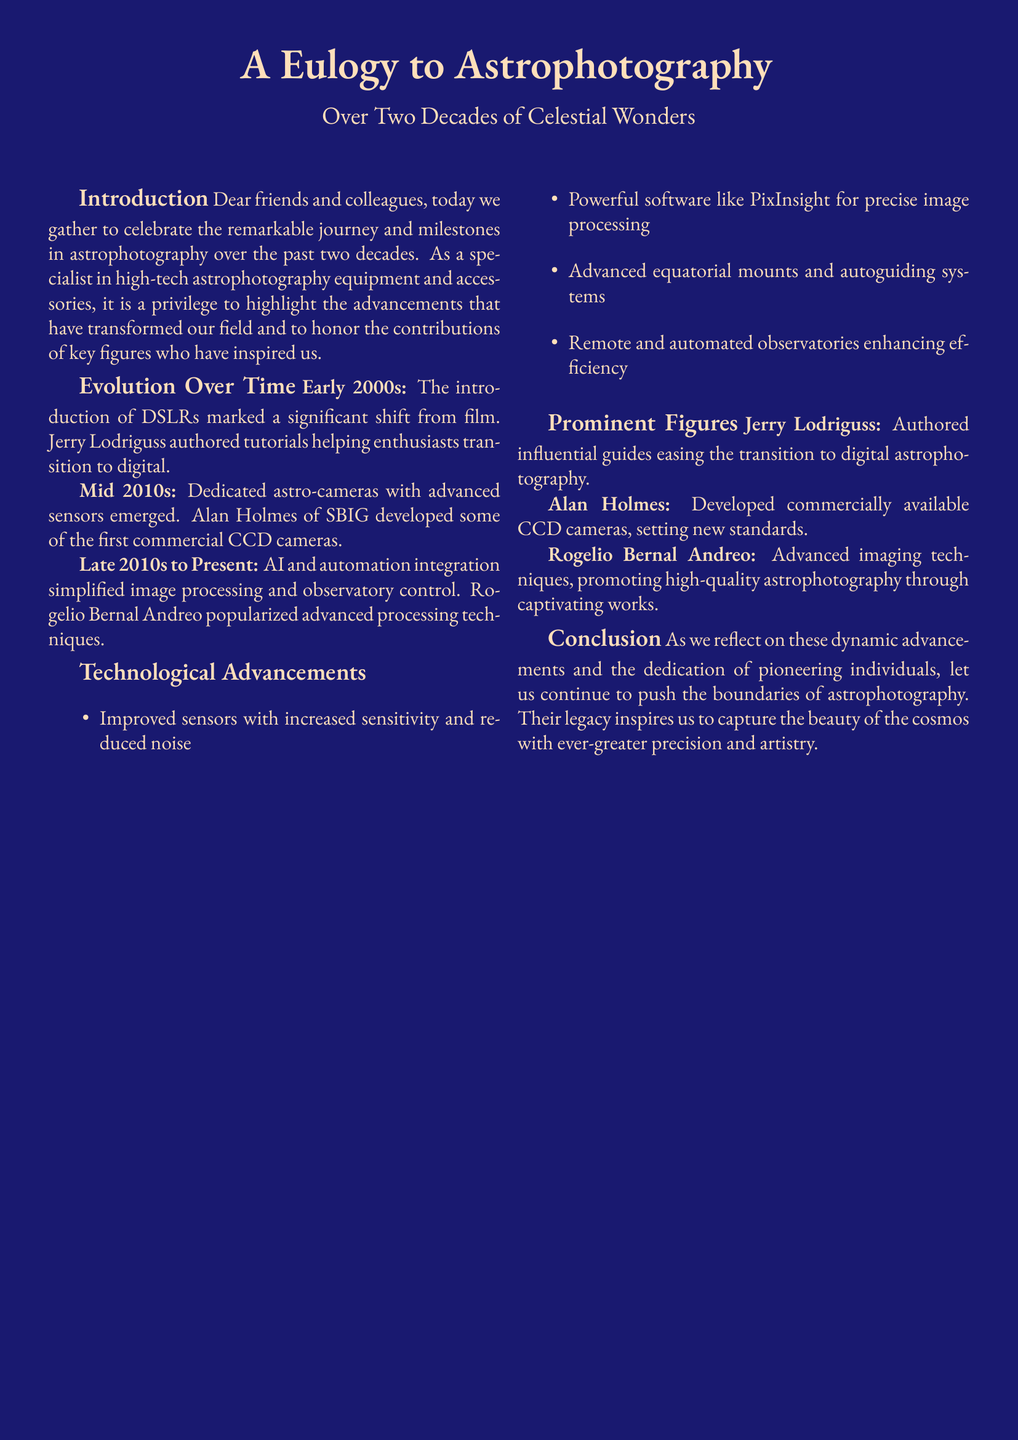What significant shift occurred in the early 2000s? The introduction of DSLRs marked a significant shift from film in astrophotography.
Answer: DSLRs Who authored tutorials for enthusiasts in the early 2000s? Jerry Lodriguss helped ease the transition to digital with his tutorials.
Answer: Jerry Lodriguss Which technology did Alan Holmes develop in the mid 2010s? Alan Holmes developed some of the first commercial CCD cameras.
Answer: CCD cameras What is a major software mentioned for image processing? The document highlights the use of PixInsight as powerful software for image processing.
Answer: PixInsight What type of advancements have improved the efficiency of observatories? Remote and automated observatories have enhanced efficiency in astrophotography.
Answer: Remote and automated observatories Who popularized advanced processing techniques in astrophotography? Rogelio Bernal Andreo is mentioned for popularizing advanced techniques.
Answer: Rogelio Bernal Andreo What contribution did Jerry Lodriguss make to the field? Jerry Lodriguss authored influential guides easing the transition to digital astrophotography.
Answer: Influential guides What era marks the emergence of dedicated astro-cameras? The mid 2010s is when dedicated astro-cameras with advanced sensors began to emerge.
Answer: Mid 2010s What is the color of the page background in the document? The background color used in the document is spaceblue.
Answer: spaceblue 